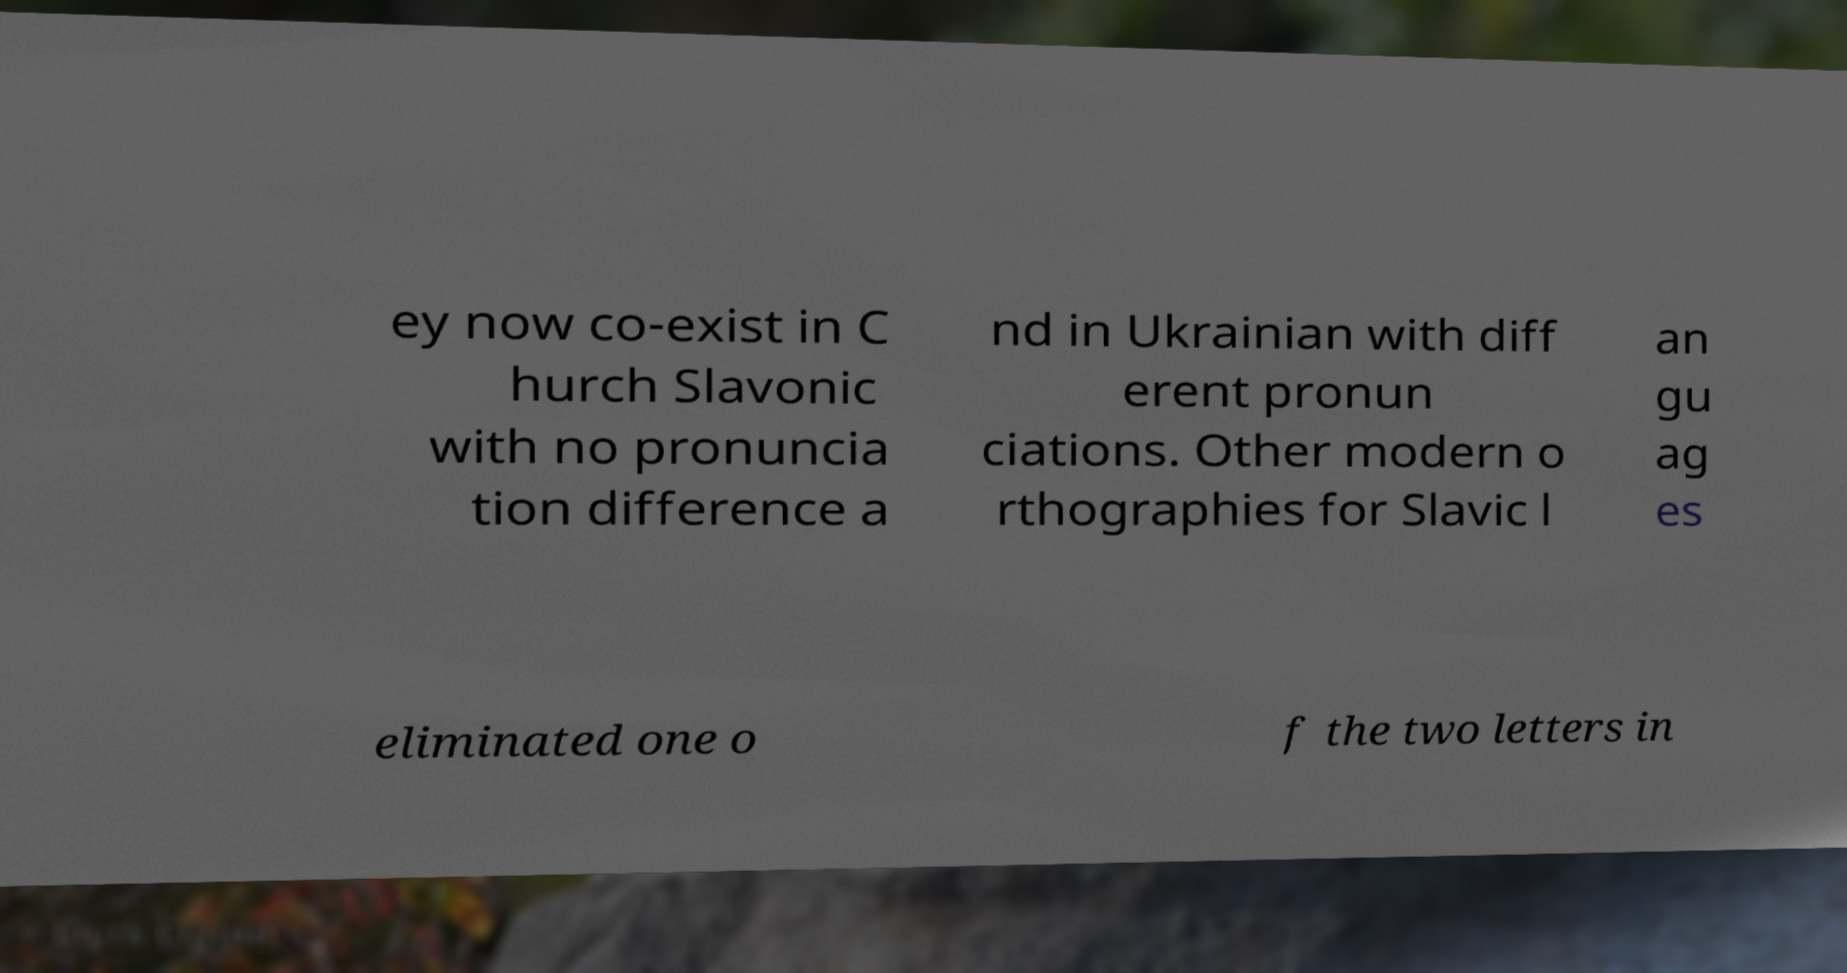Can you accurately transcribe the text from the provided image for me? ey now co-exist in C hurch Slavonic with no pronuncia tion difference a nd in Ukrainian with diff erent pronun ciations. Other modern o rthographies for Slavic l an gu ag es eliminated one o f the two letters in 